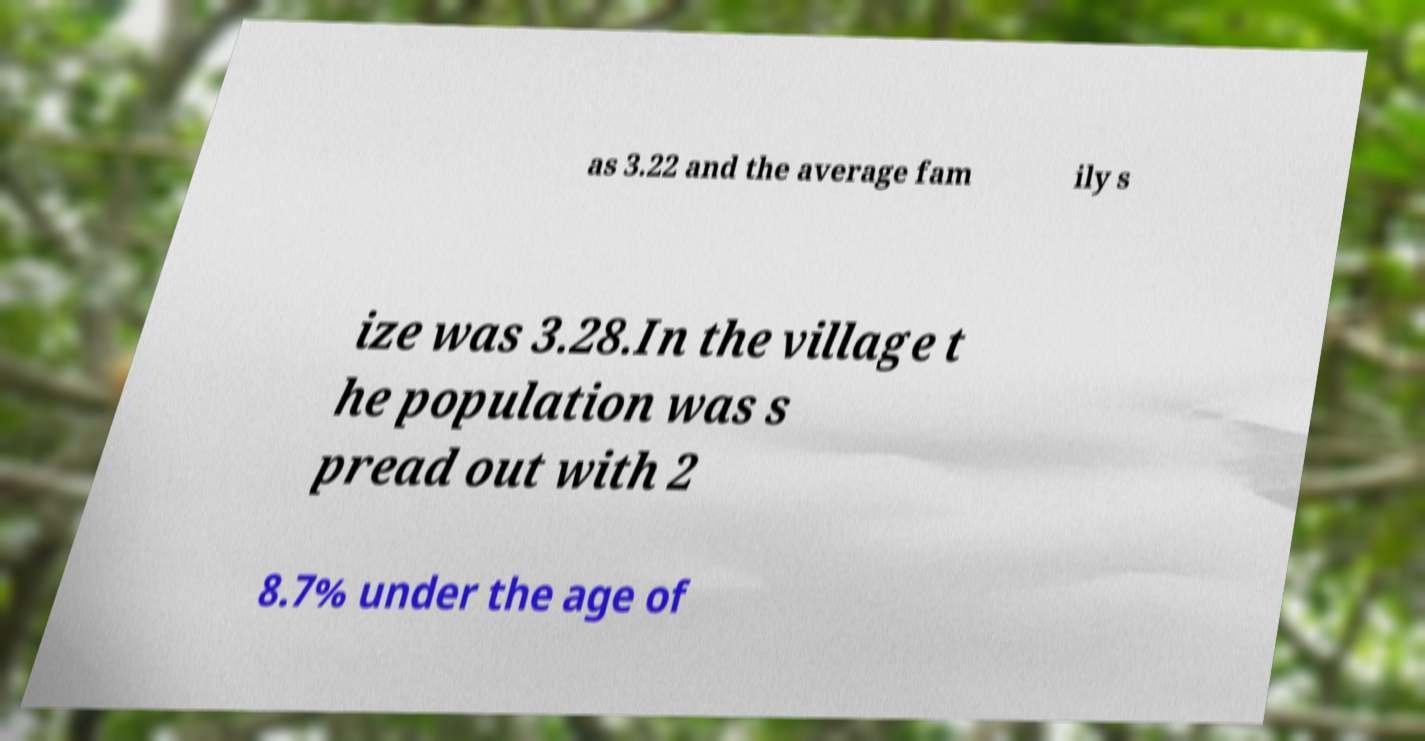Could you assist in decoding the text presented in this image and type it out clearly? as 3.22 and the average fam ily s ize was 3.28.In the village t he population was s pread out with 2 8.7% under the age of 